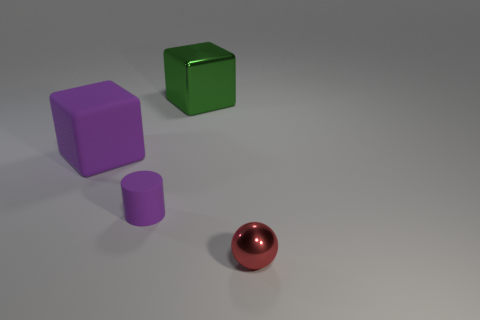The purple cylinder has what size?
Your answer should be very brief. Small. There is a block on the right side of the tiny thing to the left of the tiny ball; is there a tiny red shiny thing that is in front of it?
Make the answer very short. Yes. What number of tiny things are rubber balls or rubber cylinders?
Provide a short and direct response. 1. Is there any other thing that is the same color as the large metallic block?
Your response must be concise. No. Do the cube that is in front of the green block and the cylinder have the same size?
Make the answer very short. No. What is the color of the small thing that is left of the block that is behind the purple object behind the small purple cylinder?
Give a very brief answer. Purple. The small metal object has what color?
Offer a terse response. Red. Does the matte cylinder have the same color as the large matte object?
Ensure brevity in your answer.  Yes. Is the large cube on the right side of the purple matte cube made of the same material as the sphere in front of the matte cube?
Give a very brief answer. Yes. There is a large green thing that is the same shape as the large purple thing; what is it made of?
Your answer should be very brief. Metal. 